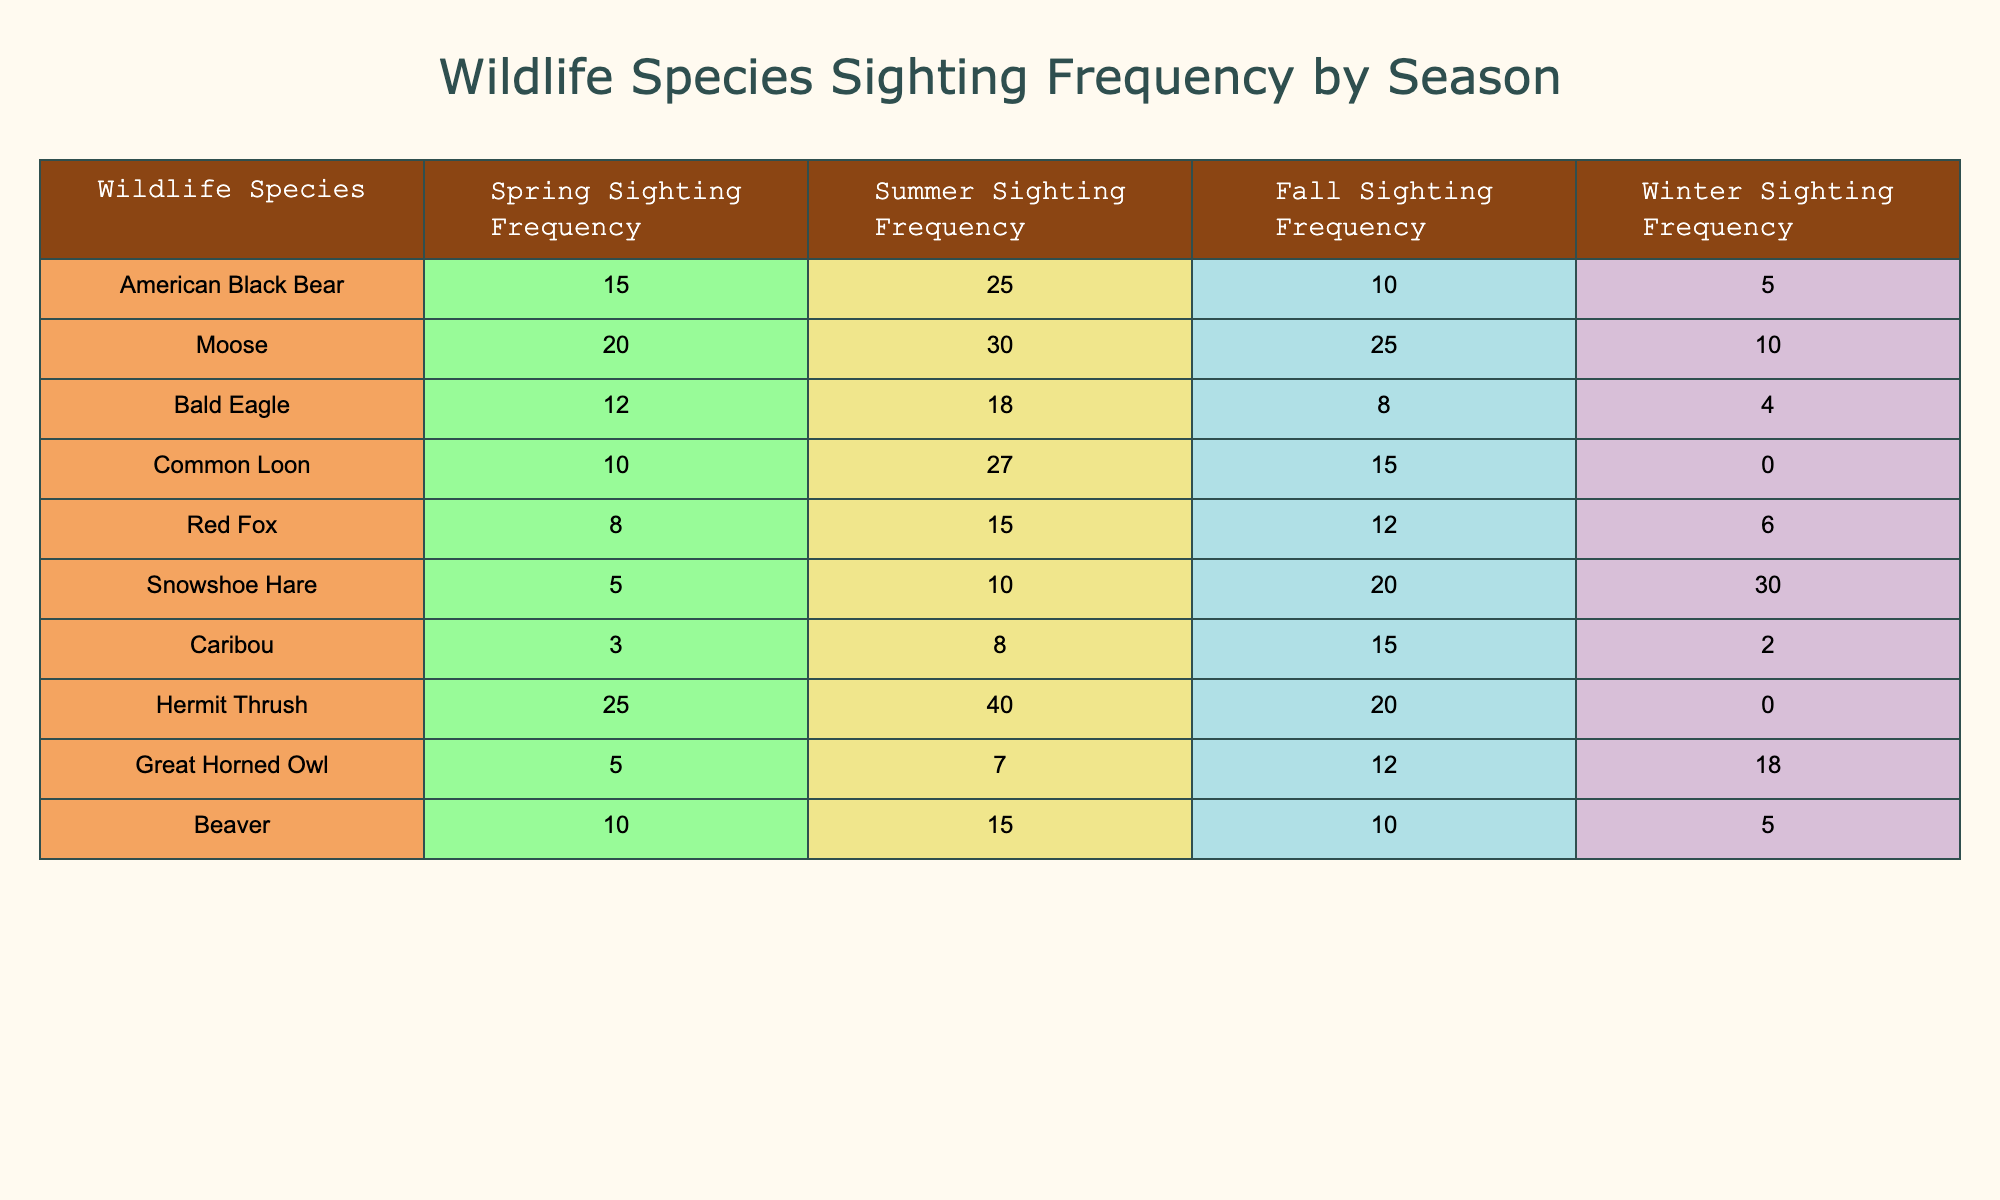What's the summer sighting frequency of the Moose? Referring to the table, the Moose has a summer sighting frequency of 30.
Answer: 30 Which species has the highest sighting frequency in winter? Looking at the winter sighting frequencies, the Snowshoe Hare has 30, which is higher than all other species.
Answer: Snowshoe Hare What is the total sighting frequency of the American Black Bear across all seasons? To calculate the total, we sum the frequencies: 15 (spring) + 25 (summer) + 10 (fall) + 5 (winter) = 55.
Answer: 55 Which species has the lowest overall sighting frequency and what is that frequency? First, we add the sighting frequencies of all seasons for each species. The Caribou totals to 2 (winter), which is the lowest total compared to other species.
Answer: Caribou, 28 Does the Bald Eagle have a higher sighting frequency in summer than in fall? The Bald Eagle’s summer frequency is 18 and the fall frequency is 8. Since 18 is greater than 8, the answer is yes.
Answer: Yes What is the average sighting frequency for the Common Loon across all seasons? To find the average, we total its frequencies: 10 (spring) + 27 (summer) + 15 (fall) + 0 (winter) = 52. There are four seasons, so the average is 52/4 = 13.
Answer: 13 Which species has a greater seasonal frequency difference between summer and winter? We calculate the difference between summer and winter for each species. The Snowshoe Hare has a difference of 10 (summer 10 - winter 30), which is the greatest.
Answer: Snowshoe Hare Are there any species that have the same sighting frequency in spring and winter? By examining the table, the Red Fox has 8 in spring and 6 in winter, they are not the same. None of the species show equal frequencies in both seasons.
Answer: No What is the median sighting frequency for spring among the species? First, we list the spring frequencies in ascending order: 3 (Caribou), 5 (Snowshoe Hare), 8 (Red Fox), 10 (Common Loon), 12 (Bald Eagle), 15 (American Black Bear), 20 (Moose), 25 (Hermit Thrush), 5 (Beaver). The median (middle value) is 10, as there are 10 values.
Answer: 10 